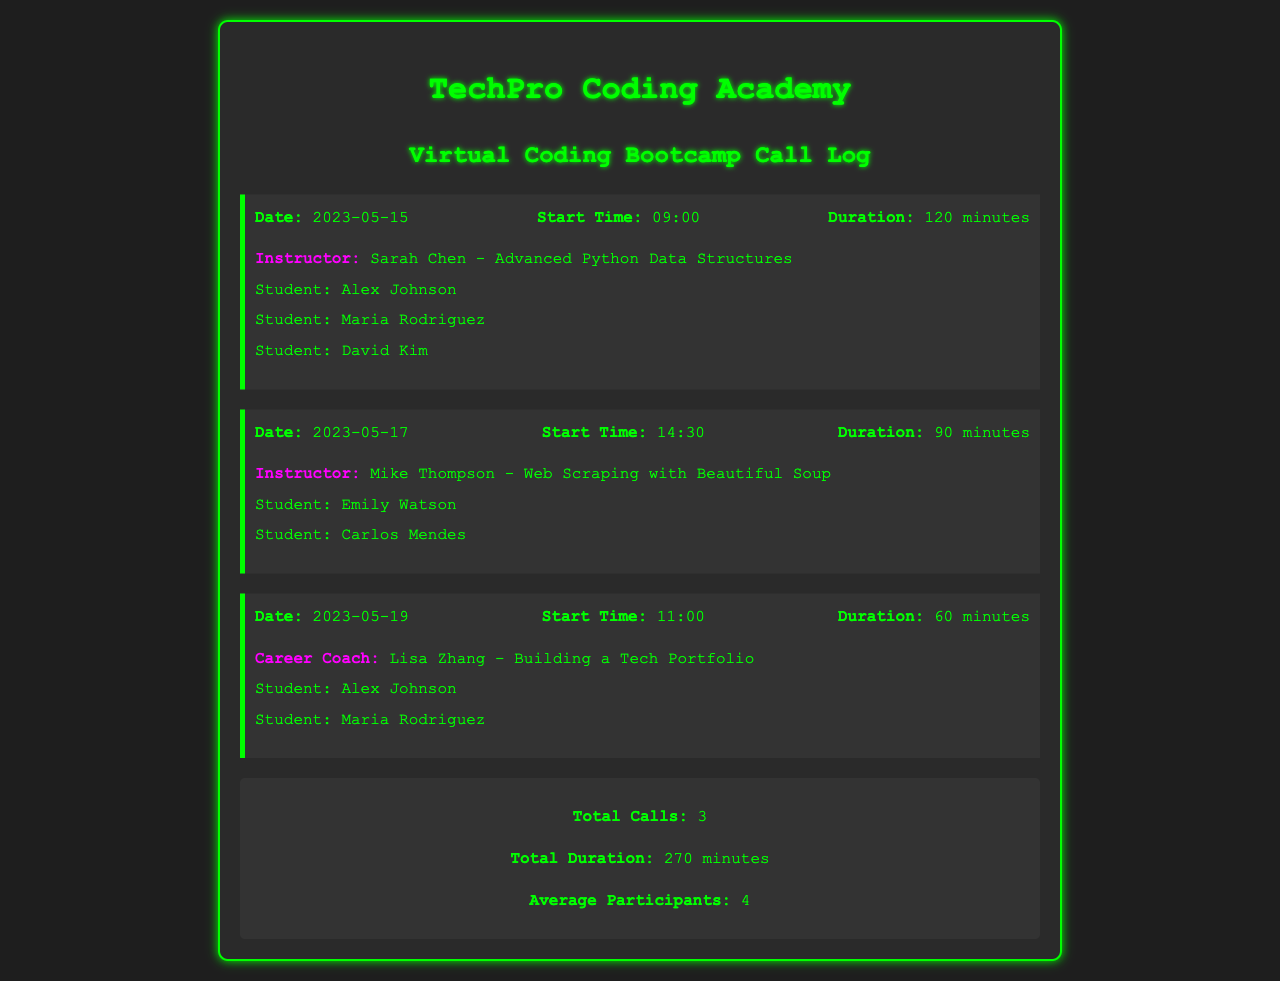What is the date of the first call? The first call is logged on May 15, 2023.
Answer: 2023-05-15 Who was the instructor for the call on May 17? The instructor for the call on May 17 was Mike Thompson.
Answer: Mike Thompson What was the duration of the call on May 19? The duration of the call on May 19 is detailed as 60 minutes.
Answer: 60 minutes How many total calls are recorded in the log? The document summarizes that there are 3 total calls.
Answer: 3 Which student attended the most calls? Alex Johnson attended both the calls on May 15 and May 19, making him the most frequent participant.
Answer: Alex Johnson What subject was covered in the first call? The first call covered Advanced Python Data Structures as noted by the instructor.
Answer: Advanced Python Data Structures What is the total duration of all calls combined? The document summarizes the total duration as 270 minutes across all calls.
Answer: 270 minutes Who was the career coach listed in the calls? Lisa Zhang is the career coach mentioned in the call log for May 19.
Answer: Lisa Zhang What is the average number of participants per call? The summary indicates that the average number of participants is 4.
Answer: 4 